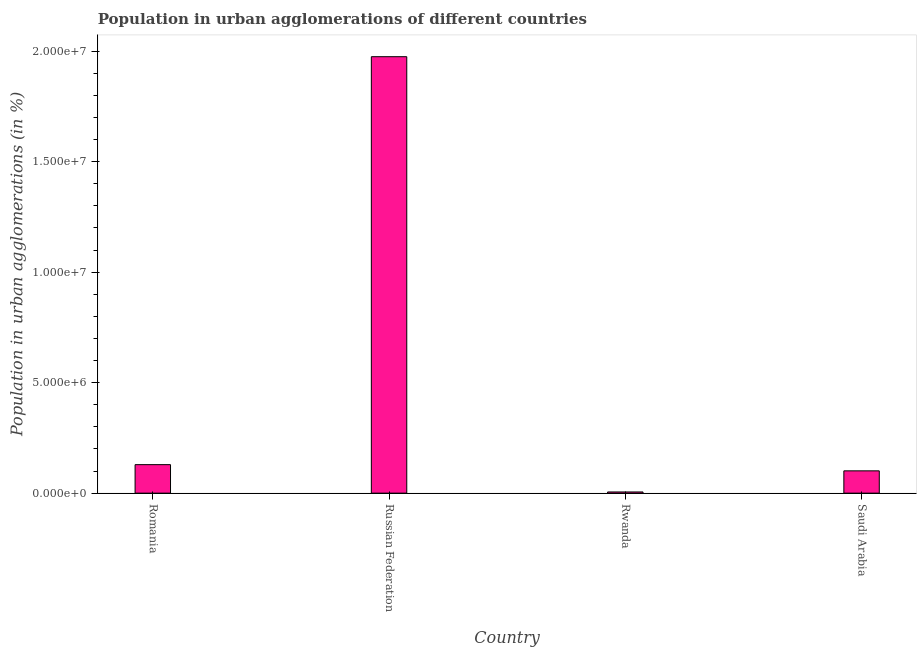Does the graph contain any zero values?
Provide a succinct answer. No. What is the title of the graph?
Offer a very short reply. Population in urban agglomerations of different countries. What is the label or title of the X-axis?
Provide a succinct answer. Country. What is the label or title of the Y-axis?
Your answer should be very brief. Population in urban agglomerations (in %). What is the population in urban agglomerations in Saudi Arabia?
Offer a very short reply. 1.01e+06. Across all countries, what is the maximum population in urban agglomerations?
Make the answer very short. 1.98e+07. Across all countries, what is the minimum population in urban agglomerations?
Ensure brevity in your answer.  5.32e+04. In which country was the population in urban agglomerations maximum?
Your answer should be very brief. Russian Federation. In which country was the population in urban agglomerations minimum?
Your answer should be very brief. Rwanda. What is the sum of the population in urban agglomerations?
Offer a very short reply. 2.21e+07. What is the difference between the population in urban agglomerations in Romania and Rwanda?
Provide a short and direct response. 1.24e+06. What is the average population in urban agglomerations per country?
Your answer should be compact. 5.53e+06. What is the median population in urban agglomerations?
Your answer should be very brief. 1.15e+06. What is the ratio of the population in urban agglomerations in Russian Federation to that in Saudi Arabia?
Your response must be concise. 19.58. What is the difference between the highest and the second highest population in urban agglomerations?
Keep it short and to the point. 1.85e+07. What is the difference between the highest and the lowest population in urban agglomerations?
Keep it short and to the point. 1.97e+07. How many bars are there?
Make the answer very short. 4. Are all the bars in the graph horizontal?
Provide a succinct answer. No. How many countries are there in the graph?
Provide a succinct answer. 4. Are the values on the major ticks of Y-axis written in scientific E-notation?
Provide a succinct answer. Yes. What is the Population in urban agglomerations (in %) of Romania?
Your answer should be compact. 1.29e+06. What is the Population in urban agglomerations (in %) in Russian Federation?
Your response must be concise. 1.98e+07. What is the Population in urban agglomerations (in %) of Rwanda?
Offer a terse response. 5.32e+04. What is the Population in urban agglomerations (in %) in Saudi Arabia?
Give a very brief answer. 1.01e+06. What is the difference between the Population in urban agglomerations (in %) in Romania and Russian Federation?
Provide a succinct answer. -1.85e+07. What is the difference between the Population in urban agglomerations (in %) in Romania and Rwanda?
Keep it short and to the point. 1.24e+06. What is the difference between the Population in urban agglomerations (in %) in Romania and Saudi Arabia?
Offer a terse response. 2.81e+05. What is the difference between the Population in urban agglomerations (in %) in Russian Federation and Rwanda?
Your answer should be compact. 1.97e+07. What is the difference between the Population in urban agglomerations (in %) in Russian Federation and Saudi Arabia?
Make the answer very short. 1.87e+07. What is the difference between the Population in urban agglomerations (in %) in Rwanda and Saudi Arabia?
Your answer should be very brief. -9.56e+05. What is the ratio of the Population in urban agglomerations (in %) in Romania to that in Russian Federation?
Keep it short and to the point. 0.07. What is the ratio of the Population in urban agglomerations (in %) in Romania to that in Rwanda?
Provide a succinct answer. 24.24. What is the ratio of the Population in urban agglomerations (in %) in Romania to that in Saudi Arabia?
Keep it short and to the point. 1.28. What is the ratio of the Population in urban agglomerations (in %) in Russian Federation to that in Rwanda?
Give a very brief answer. 371.14. What is the ratio of the Population in urban agglomerations (in %) in Russian Federation to that in Saudi Arabia?
Provide a succinct answer. 19.58. What is the ratio of the Population in urban agglomerations (in %) in Rwanda to that in Saudi Arabia?
Offer a very short reply. 0.05. 